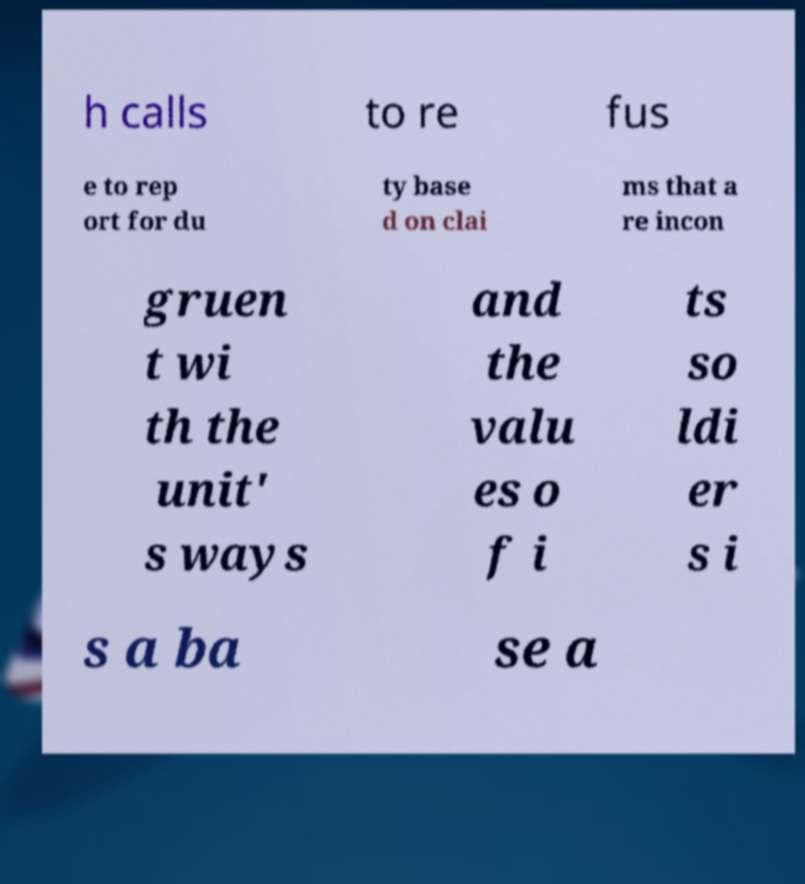Could you extract and type out the text from this image? h calls to re fus e to rep ort for du ty base d on clai ms that a re incon gruen t wi th the unit' s ways and the valu es o f i ts so ldi er s i s a ba se a 